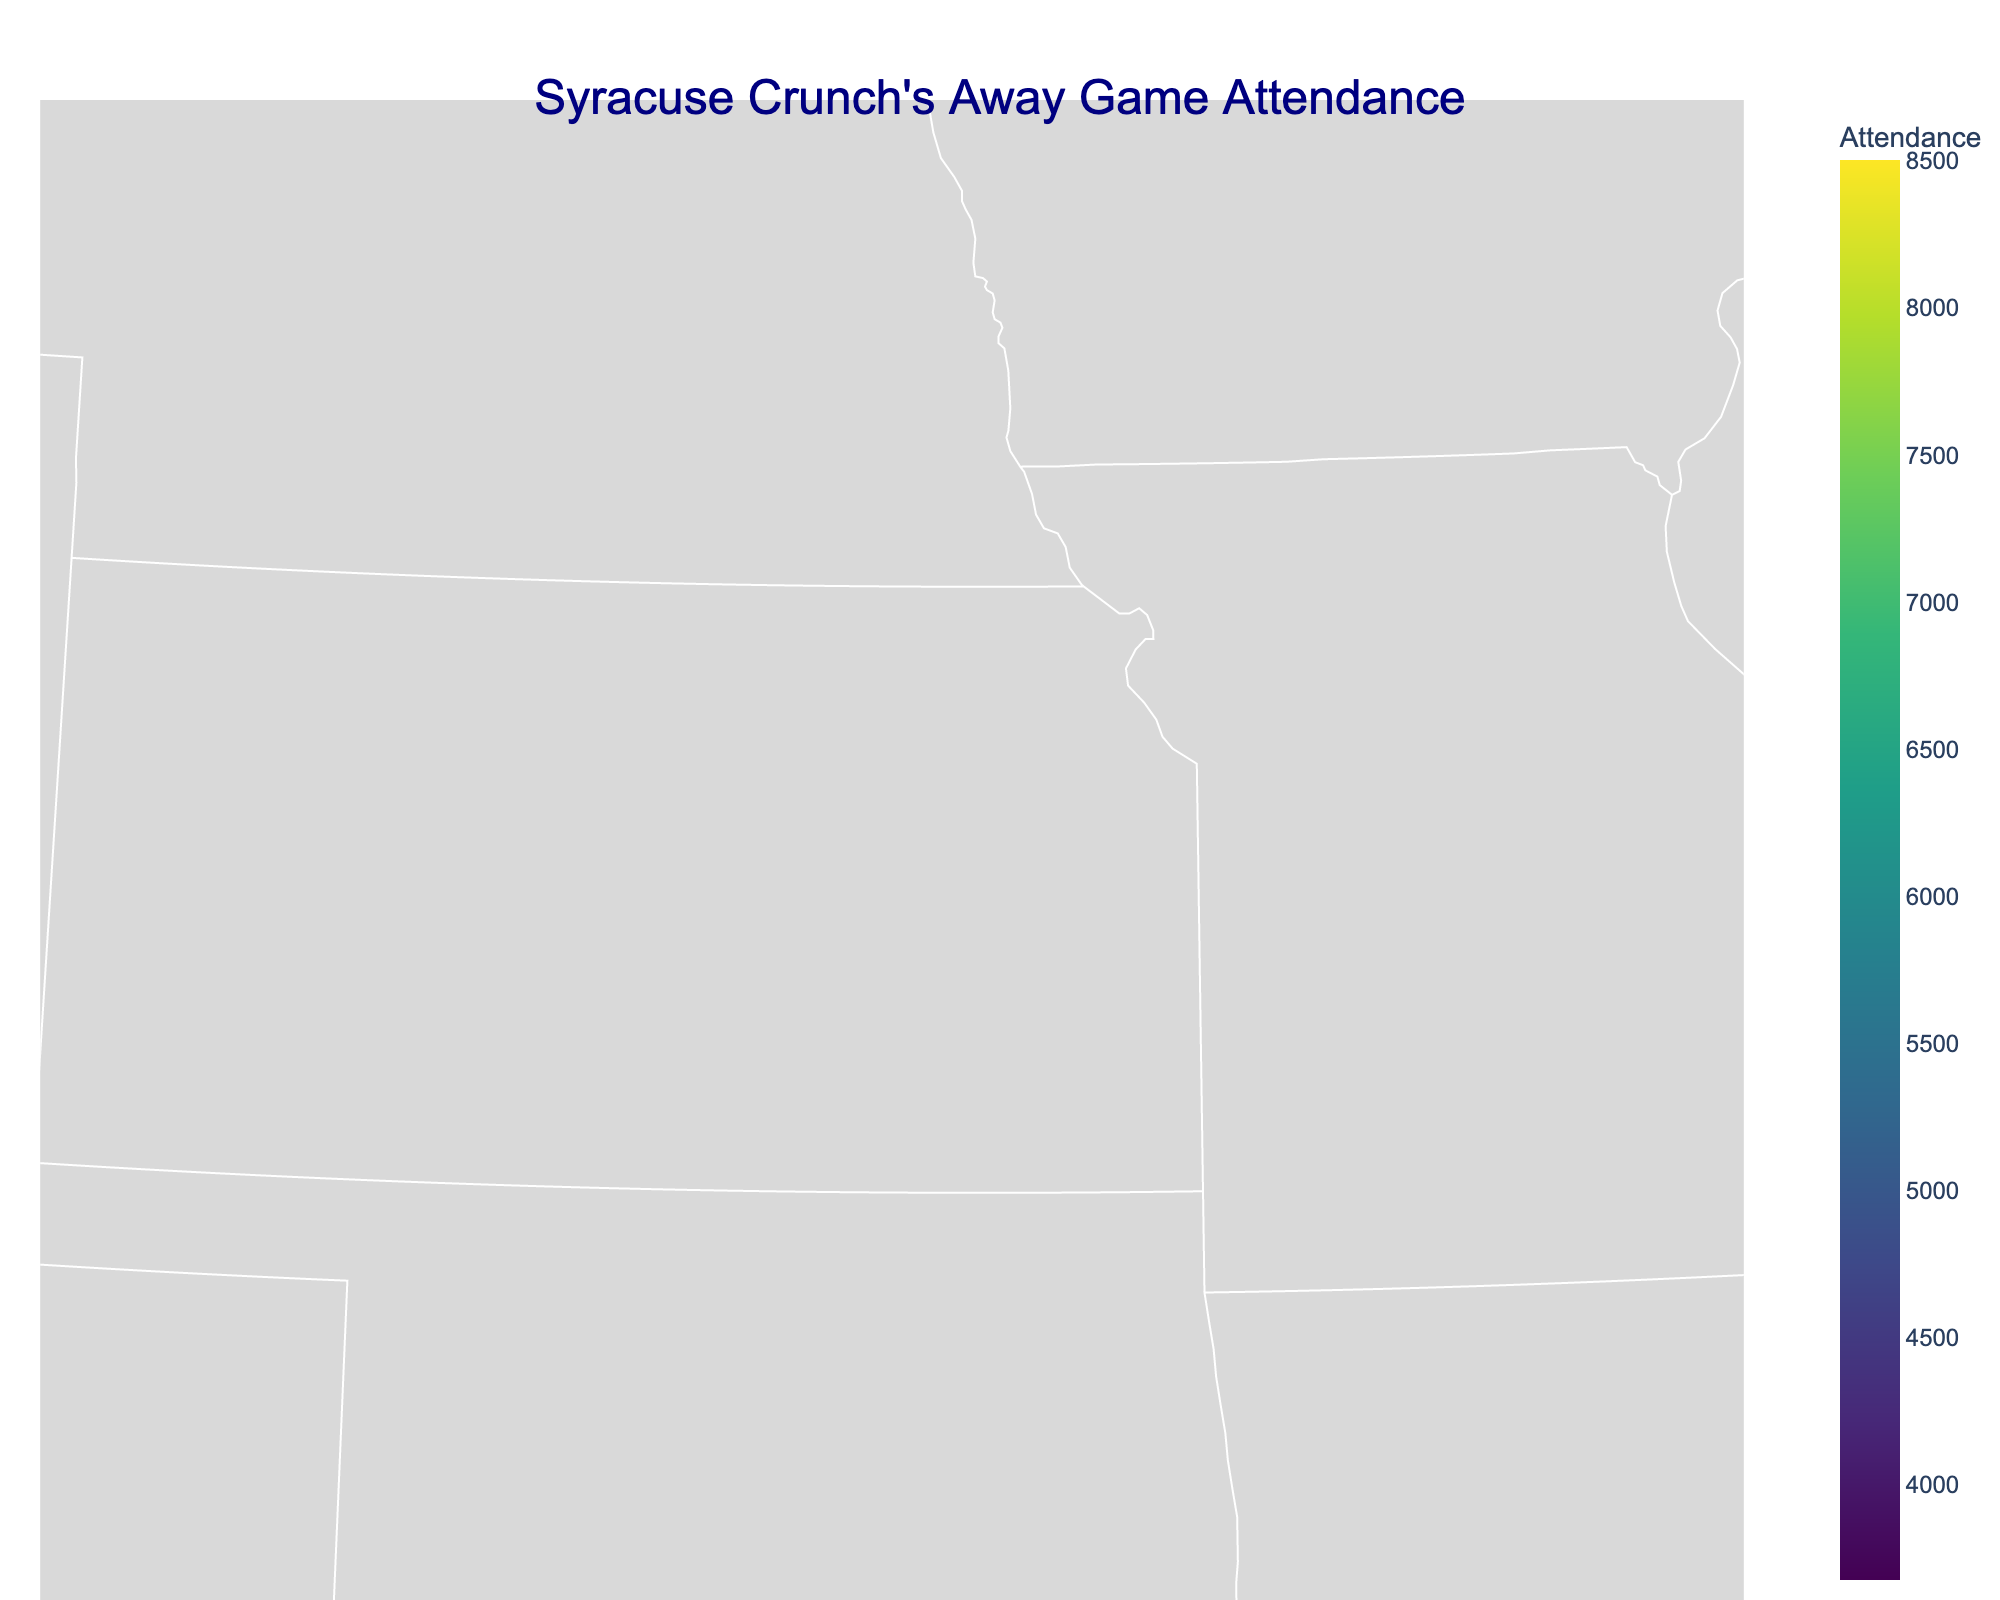Which city has the highest attendance for Syracuse Crunch's away games? To find this, look at the size and color of the marker that represents the attendance values of all cities in the plot and identify the largest, darkest marker. Hershey, PA has the largest marker.
Answer: Hershey, PA What is the size of the marker for Rochester, NY? Look at the marker representation for Rochester, NY. The size corresponds to the attendance which is 5820, and the sizes are defined as attendance divided by 200. Therefore, the size of the marker is 5820 / 200.
Answer: 29.1 Which city in Connecticut had higher attendance: Hartford or Bridgeport? Compare the marker sizes and colors for Hartford, CT and Bridgeport, CT. Hartford's attendance of 5200 is higher than Bridgeport's attendance of 4200.
Answer: Hartford, CT What is the average attendance of the games played in New York (Rochester, Utica, Binghamton, Albany)? Sum the attendances for the four New York cities: 5820 (Rochester) + 3950 (Utica) + 3675 (Binghamton) + 3800 (Albany) = 17245. Then, divide by the number of cities, 17245 / 4.
Answer: 4311.25 Which states have more than one city with recorded attendance values? Identify the states with more than one data point in the plot. New York has Rochester, Utica, Binghamton, and Albany; Pennsylvania has Hershey and Wilkes-Barre; Connecticut has Hartford and Bridgeport.
Answer: New York, Pennsylvania, Connecticut What's the total attendance for all away games in Pennsylvania? Sum the attendance values for Hershey, PA and Wilkes-Barre, PA. Hershey has 8500 and Wilkes-Barre has 6100. Therefore, 8500 + 6100.
Answer: 14600 How does the attendance of Providence, RI compare to that of the other cities? Find the marker for Providence, RI and compare its color and size, which represents 7100, to other cities. Only Hershey, PA has a higher attendance at 8500.
Answer: Second highest What is the median attendance of all the cities listed? List the attendance values in ascending order: 3675, 3800, 3950, 4200, 4800, 5200, 5820, 6100, 7100, 8500. The median is the average of the 5th and 6th values (4800 and 5200). (4800 + 5200) / 2.
Answer: 5000 Which city is located at 41.1792 latitude and -73.1894 longitude? Look for the city corresponding to these coordinates in the plot data. The city matching these coordinates is Bridgeport, CT.
Answer: Bridgeport, CT 